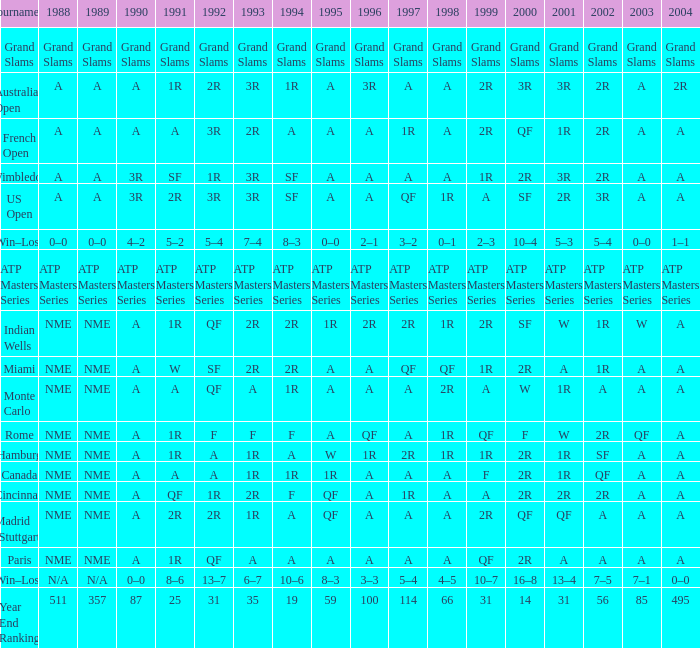What displays for 2002 when the 1991 is w? 1R. 